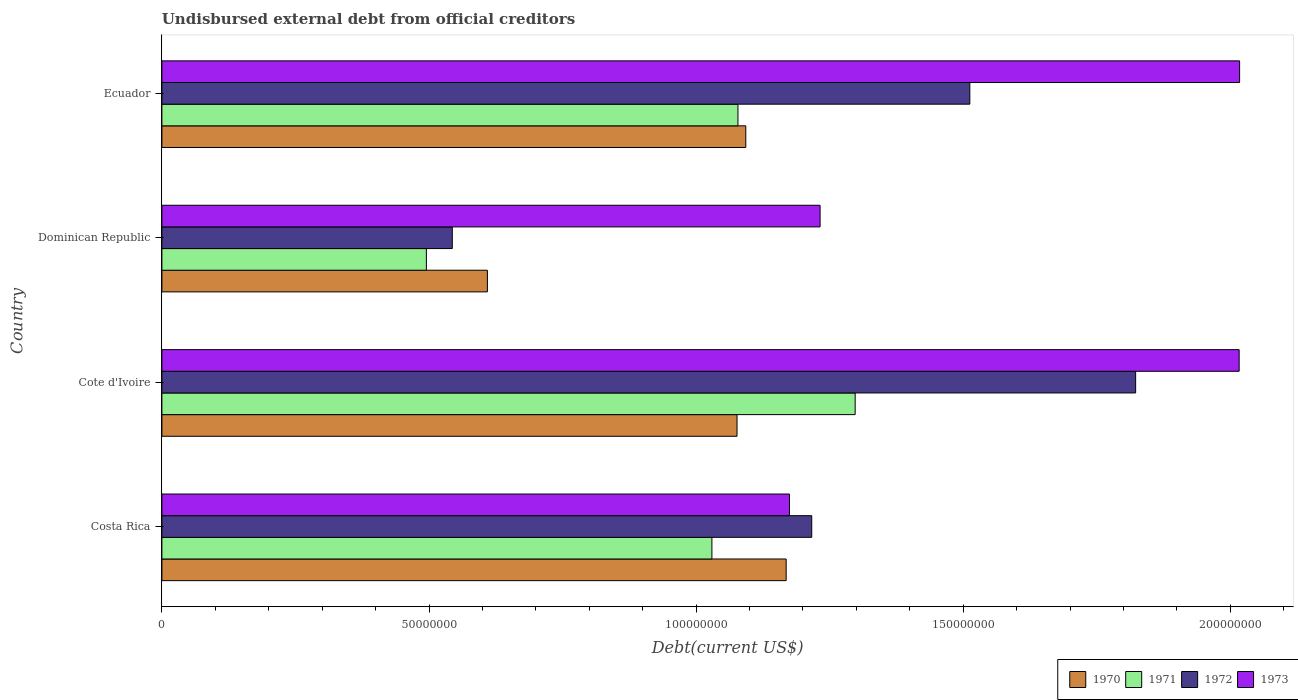How many different coloured bars are there?
Provide a succinct answer. 4. How many groups of bars are there?
Make the answer very short. 4. How many bars are there on the 3rd tick from the top?
Keep it short and to the point. 4. What is the label of the 3rd group of bars from the top?
Provide a succinct answer. Cote d'Ivoire. What is the total debt in 1972 in Costa Rica?
Offer a terse response. 1.22e+08. Across all countries, what is the maximum total debt in 1973?
Keep it short and to the point. 2.02e+08. Across all countries, what is the minimum total debt in 1970?
Offer a terse response. 6.09e+07. What is the total total debt in 1973 in the graph?
Provide a short and direct response. 6.44e+08. What is the difference between the total debt in 1971 in Dominican Republic and that in Ecuador?
Keep it short and to the point. -5.83e+07. What is the difference between the total debt in 1972 in Costa Rica and the total debt in 1970 in Cote d'Ivoire?
Make the answer very short. 1.40e+07. What is the average total debt in 1973 per country?
Your answer should be very brief. 1.61e+08. What is the difference between the total debt in 1971 and total debt in 1972 in Ecuador?
Your answer should be very brief. -4.34e+07. What is the ratio of the total debt in 1970 in Dominican Republic to that in Ecuador?
Offer a very short reply. 0.56. Is the total debt in 1970 in Costa Rica less than that in Cote d'Ivoire?
Give a very brief answer. No. Is the difference between the total debt in 1971 in Costa Rica and Ecuador greater than the difference between the total debt in 1972 in Costa Rica and Ecuador?
Your response must be concise. Yes. What is the difference between the highest and the second highest total debt in 1972?
Your answer should be compact. 3.10e+07. What is the difference between the highest and the lowest total debt in 1972?
Offer a terse response. 1.28e+08. In how many countries, is the total debt in 1972 greater than the average total debt in 1972 taken over all countries?
Offer a terse response. 2. What does the 3rd bar from the top in Ecuador represents?
Your answer should be compact. 1971. Is it the case that in every country, the sum of the total debt in 1971 and total debt in 1970 is greater than the total debt in 1972?
Give a very brief answer. Yes. How many bars are there?
Your answer should be compact. 16. Does the graph contain grids?
Make the answer very short. No. How many legend labels are there?
Provide a short and direct response. 4. How are the legend labels stacked?
Offer a terse response. Horizontal. What is the title of the graph?
Provide a succinct answer. Undisbursed external debt from official creditors. Does "2002" appear as one of the legend labels in the graph?
Keep it short and to the point. No. What is the label or title of the X-axis?
Ensure brevity in your answer.  Debt(current US$). What is the label or title of the Y-axis?
Offer a terse response. Country. What is the Debt(current US$) in 1970 in Costa Rica?
Provide a short and direct response. 1.17e+08. What is the Debt(current US$) in 1971 in Costa Rica?
Provide a succinct answer. 1.03e+08. What is the Debt(current US$) in 1972 in Costa Rica?
Ensure brevity in your answer.  1.22e+08. What is the Debt(current US$) of 1973 in Costa Rica?
Your answer should be compact. 1.17e+08. What is the Debt(current US$) of 1970 in Cote d'Ivoire?
Give a very brief answer. 1.08e+08. What is the Debt(current US$) of 1971 in Cote d'Ivoire?
Provide a succinct answer. 1.30e+08. What is the Debt(current US$) in 1972 in Cote d'Ivoire?
Provide a short and direct response. 1.82e+08. What is the Debt(current US$) of 1973 in Cote d'Ivoire?
Your response must be concise. 2.02e+08. What is the Debt(current US$) in 1970 in Dominican Republic?
Keep it short and to the point. 6.09e+07. What is the Debt(current US$) of 1971 in Dominican Republic?
Your answer should be compact. 4.95e+07. What is the Debt(current US$) in 1972 in Dominican Republic?
Provide a succinct answer. 5.44e+07. What is the Debt(current US$) in 1973 in Dominican Republic?
Ensure brevity in your answer.  1.23e+08. What is the Debt(current US$) in 1970 in Ecuador?
Provide a short and direct response. 1.09e+08. What is the Debt(current US$) in 1971 in Ecuador?
Offer a very short reply. 1.08e+08. What is the Debt(current US$) in 1972 in Ecuador?
Give a very brief answer. 1.51e+08. What is the Debt(current US$) of 1973 in Ecuador?
Provide a succinct answer. 2.02e+08. Across all countries, what is the maximum Debt(current US$) of 1970?
Offer a terse response. 1.17e+08. Across all countries, what is the maximum Debt(current US$) in 1971?
Give a very brief answer. 1.30e+08. Across all countries, what is the maximum Debt(current US$) of 1972?
Keep it short and to the point. 1.82e+08. Across all countries, what is the maximum Debt(current US$) in 1973?
Offer a very short reply. 2.02e+08. Across all countries, what is the minimum Debt(current US$) in 1970?
Your answer should be compact. 6.09e+07. Across all countries, what is the minimum Debt(current US$) in 1971?
Your answer should be compact. 4.95e+07. Across all countries, what is the minimum Debt(current US$) of 1972?
Give a very brief answer. 5.44e+07. Across all countries, what is the minimum Debt(current US$) in 1973?
Give a very brief answer. 1.17e+08. What is the total Debt(current US$) of 1970 in the graph?
Keep it short and to the point. 3.95e+08. What is the total Debt(current US$) in 1971 in the graph?
Your answer should be very brief. 3.90e+08. What is the total Debt(current US$) of 1972 in the graph?
Ensure brevity in your answer.  5.09e+08. What is the total Debt(current US$) of 1973 in the graph?
Your answer should be very brief. 6.44e+08. What is the difference between the Debt(current US$) of 1970 in Costa Rica and that in Cote d'Ivoire?
Your response must be concise. 9.20e+06. What is the difference between the Debt(current US$) in 1971 in Costa Rica and that in Cote d'Ivoire?
Provide a succinct answer. -2.68e+07. What is the difference between the Debt(current US$) of 1972 in Costa Rica and that in Cote d'Ivoire?
Your response must be concise. -6.06e+07. What is the difference between the Debt(current US$) of 1973 in Costa Rica and that in Cote d'Ivoire?
Offer a terse response. -8.42e+07. What is the difference between the Debt(current US$) of 1970 in Costa Rica and that in Dominican Republic?
Give a very brief answer. 5.59e+07. What is the difference between the Debt(current US$) of 1971 in Costa Rica and that in Dominican Republic?
Your answer should be very brief. 5.34e+07. What is the difference between the Debt(current US$) in 1972 in Costa Rica and that in Dominican Republic?
Your answer should be very brief. 6.73e+07. What is the difference between the Debt(current US$) of 1973 in Costa Rica and that in Dominican Republic?
Your answer should be compact. -5.73e+06. What is the difference between the Debt(current US$) of 1970 in Costa Rica and that in Ecuador?
Provide a succinct answer. 7.56e+06. What is the difference between the Debt(current US$) in 1971 in Costa Rica and that in Ecuador?
Ensure brevity in your answer.  -4.88e+06. What is the difference between the Debt(current US$) in 1972 in Costa Rica and that in Ecuador?
Make the answer very short. -2.96e+07. What is the difference between the Debt(current US$) in 1973 in Costa Rica and that in Ecuador?
Offer a terse response. -8.43e+07. What is the difference between the Debt(current US$) in 1970 in Cote d'Ivoire and that in Dominican Republic?
Offer a terse response. 4.67e+07. What is the difference between the Debt(current US$) in 1971 in Cote d'Ivoire and that in Dominican Republic?
Ensure brevity in your answer.  8.03e+07. What is the difference between the Debt(current US$) of 1972 in Cote d'Ivoire and that in Dominican Republic?
Provide a succinct answer. 1.28e+08. What is the difference between the Debt(current US$) in 1973 in Cote d'Ivoire and that in Dominican Republic?
Keep it short and to the point. 7.84e+07. What is the difference between the Debt(current US$) of 1970 in Cote d'Ivoire and that in Ecuador?
Your answer should be compact. -1.64e+06. What is the difference between the Debt(current US$) in 1971 in Cote d'Ivoire and that in Ecuador?
Your response must be concise. 2.19e+07. What is the difference between the Debt(current US$) of 1972 in Cote d'Ivoire and that in Ecuador?
Give a very brief answer. 3.10e+07. What is the difference between the Debt(current US$) of 1973 in Cote d'Ivoire and that in Ecuador?
Make the answer very short. -8.40e+04. What is the difference between the Debt(current US$) in 1970 in Dominican Republic and that in Ecuador?
Provide a short and direct response. -4.84e+07. What is the difference between the Debt(current US$) of 1971 in Dominican Republic and that in Ecuador?
Offer a very short reply. -5.83e+07. What is the difference between the Debt(current US$) in 1972 in Dominican Republic and that in Ecuador?
Your response must be concise. -9.69e+07. What is the difference between the Debt(current US$) in 1973 in Dominican Republic and that in Ecuador?
Make the answer very short. -7.85e+07. What is the difference between the Debt(current US$) in 1970 in Costa Rica and the Debt(current US$) in 1971 in Cote d'Ivoire?
Your answer should be very brief. -1.29e+07. What is the difference between the Debt(current US$) in 1970 in Costa Rica and the Debt(current US$) in 1972 in Cote d'Ivoire?
Your answer should be very brief. -6.54e+07. What is the difference between the Debt(current US$) in 1970 in Costa Rica and the Debt(current US$) in 1973 in Cote d'Ivoire?
Make the answer very short. -8.48e+07. What is the difference between the Debt(current US$) in 1971 in Costa Rica and the Debt(current US$) in 1972 in Cote d'Ivoire?
Give a very brief answer. -7.93e+07. What is the difference between the Debt(current US$) of 1971 in Costa Rica and the Debt(current US$) of 1973 in Cote d'Ivoire?
Offer a very short reply. -9.87e+07. What is the difference between the Debt(current US$) in 1972 in Costa Rica and the Debt(current US$) in 1973 in Cote d'Ivoire?
Ensure brevity in your answer.  -8.00e+07. What is the difference between the Debt(current US$) in 1970 in Costa Rica and the Debt(current US$) in 1971 in Dominican Republic?
Provide a short and direct response. 6.73e+07. What is the difference between the Debt(current US$) of 1970 in Costa Rica and the Debt(current US$) of 1972 in Dominican Republic?
Provide a short and direct response. 6.25e+07. What is the difference between the Debt(current US$) in 1970 in Costa Rica and the Debt(current US$) in 1973 in Dominican Republic?
Offer a terse response. -6.35e+06. What is the difference between the Debt(current US$) in 1971 in Costa Rica and the Debt(current US$) in 1972 in Dominican Republic?
Give a very brief answer. 4.86e+07. What is the difference between the Debt(current US$) in 1971 in Costa Rica and the Debt(current US$) in 1973 in Dominican Republic?
Give a very brief answer. -2.02e+07. What is the difference between the Debt(current US$) in 1972 in Costa Rica and the Debt(current US$) in 1973 in Dominican Republic?
Keep it short and to the point. -1.56e+06. What is the difference between the Debt(current US$) of 1970 in Costa Rica and the Debt(current US$) of 1971 in Ecuador?
Your answer should be very brief. 9.03e+06. What is the difference between the Debt(current US$) in 1970 in Costa Rica and the Debt(current US$) in 1972 in Ecuador?
Provide a succinct answer. -3.44e+07. What is the difference between the Debt(current US$) of 1970 in Costa Rica and the Debt(current US$) of 1973 in Ecuador?
Your response must be concise. -8.49e+07. What is the difference between the Debt(current US$) of 1971 in Costa Rica and the Debt(current US$) of 1972 in Ecuador?
Your answer should be very brief. -4.83e+07. What is the difference between the Debt(current US$) in 1971 in Costa Rica and the Debt(current US$) in 1973 in Ecuador?
Provide a succinct answer. -9.88e+07. What is the difference between the Debt(current US$) of 1972 in Costa Rica and the Debt(current US$) of 1973 in Ecuador?
Offer a very short reply. -8.01e+07. What is the difference between the Debt(current US$) of 1970 in Cote d'Ivoire and the Debt(current US$) of 1971 in Dominican Republic?
Your answer should be very brief. 5.81e+07. What is the difference between the Debt(current US$) in 1970 in Cote d'Ivoire and the Debt(current US$) in 1972 in Dominican Republic?
Provide a succinct answer. 5.33e+07. What is the difference between the Debt(current US$) in 1970 in Cote d'Ivoire and the Debt(current US$) in 1973 in Dominican Republic?
Offer a very short reply. -1.55e+07. What is the difference between the Debt(current US$) of 1971 in Cote d'Ivoire and the Debt(current US$) of 1972 in Dominican Republic?
Your response must be concise. 7.54e+07. What is the difference between the Debt(current US$) in 1971 in Cote d'Ivoire and the Debt(current US$) in 1973 in Dominican Republic?
Provide a short and direct response. 6.57e+06. What is the difference between the Debt(current US$) of 1972 in Cote d'Ivoire and the Debt(current US$) of 1973 in Dominican Republic?
Provide a succinct answer. 5.91e+07. What is the difference between the Debt(current US$) in 1970 in Cote d'Ivoire and the Debt(current US$) in 1971 in Ecuador?
Your answer should be compact. -1.73e+05. What is the difference between the Debt(current US$) in 1970 in Cote d'Ivoire and the Debt(current US$) in 1972 in Ecuador?
Give a very brief answer. -4.36e+07. What is the difference between the Debt(current US$) in 1970 in Cote d'Ivoire and the Debt(current US$) in 1973 in Ecuador?
Make the answer very short. -9.41e+07. What is the difference between the Debt(current US$) in 1971 in Cote d'Ivoire and the Debt(current US$) in 1972 in Ecuador?
Offer a very short reply. -2.15e+07. What is the difference between the Debt(current US$) of 1971 in Cote d'Ivoire and the Debt(current US$) of 1973 in Ecuador?
Your response must be concise. -7.20e+07. What is the difference between the Debt(current US$) in 1972 in Cote d'Ivoire and the Debt(current US$) in 1973 in Ecuador?
Give a very brief answer. -1.95e+07. What is the difference between the Debt(current US$) of 1970 in Dominican Republic and the Debt(current US$) of 1971 in Ecuador?
Your answer should be compact. -4.69e+07. What is the difference between the Debt(current US$) in 1970 in Dominican Republic and the Debt(current US$) in 1972 in Ecuador?
Provide a short and direct response. -9.03e+07. What is the difference between the Debt(current US$) of 1970 in Dominican Republic and the Debt(current US$) of 1973 in Ecuador?
Provide a short and direct response. -1.41e+08. What is the difference between the Debt(current US$) in 1971 in Dominican Republic and the Debt(current US$) in 1972 in Ecuador?
Offer a terse response. -1.02e+08. What is the difference between the Debt(current US$) in 1971 in Dominican Republic and the Debt(current US$) in 1973 in Ecuador?
Provide a succinct answer. -1.52e+08. What is the difference between the Debt(current US$) in 1972 in Dominican Republic and the Debt(current US$) in 1973 in Ecuador?
Give a very brief answer. -1.47e+08. What is the average Debt(current US$) of 1970 per country?
Your response must be concise. 9.87e+07. What is the average Debt(current US$) in 1971 per country?
Your answer should be compact. 9.75e+07. What is the average Debt(current US$) in 1972 per country?
Your answer should be very brief. 1.27e+08. What is the average Debt(current US$) of 1973 per country?
Your answer should be very brief. 1.61e+08. What is the difference between the Debt(current US$) of 1970 and Debt(current US$) of 1971 in Costa Rica?
Make the answer very short. 1.39e+07. What is the difference between the Debt(current US$) in 1970 and Debt(current US$) in 1972 in Costa Rica?
Offer a terse response. -4.78e+06. What is the difference between the Debt(current US$) of 1970 and Debt(current US$) of 1973 in Costa Rica?
Offer a terse response. -6.18e+05. What is the difference between the Debt(current US$) of 1971 and Debt(current US$) of 1972 in Costa Rica?
Provide a succinct answer. -1.87e+07. What is the difference between the Debt(current US$) of 1971 and Debt(current US$) of 1973 in Costa Rica?
Your answer should be very brief. -1.45e+07. What is the difference between the Debt(current US$) in 1972 and Debt(current US$) in 1973 in Costa Rica?
Make the answer very short. 4.17e+06. What is the difference between the Debt(current US$) in 1970 and Debt(current US$) in 1971 in Cote d'Ivoire?
Give a very brief answer. -2.21e+07. What is the difference between the Debt(current US$) in 1970 and Debt(current US$) in 1972 in Cote d'Ivoire?
Ensure brevity in your answer.  -7.46e+07. What is the difference between the Debt(current US$) of 1970 and Debt(current US$) of 1973 in Cote d'Ivoire?
Ensure brevity in your answer.  -9.40e+07. What is the difference between the Debt(current US$) of 1971 and Debt(current US$) of 1972 in Cote d'Ivoire?
Provide a short and direct response. -5.25e+07. What is the difference between the Debt(current US$) in 1971 and Debt(current US$) in 1973 in Cote d'Ivoire?
Ensure brevity in your answer.  -7.19e+07. What is the difference between the Debt(current US$) in 1972 and Debt(current US$) in 1973 in Cote d'Ivoire?
Your response must be concise. -1.94e+07. What is the difference between the Debt(current US$) of 1970 and Debt(current US$) of 1971 in Dominican Republic?
Provide a succinct answer. 1.14e+07. What is the difference between the Debt(current US$) of 1970 and Debt(current US$) of 1972 in Dominican Republic?
Provide a short and direct response. 6.57e+06. What is the difference between the Debt(current US$) of 1970 and Debt(current US$) of 1973 in Dominican Republic?
Offer a very short reply. -6.23e+07. What is the difference between the Debt(current US$) of 1971 and Debt(current US$) of 1972 in Dominican Republic?
Your answer should be compact. -4.85e+06. What is the difference between the Debt(current US$) in 1971 and Debt(current US$) in 1973 in Dominican Republic?
Your answer should be very brief. -7.37e+07. What is the difference between the Debt(current US$) in 1972 and Debt(current US$) in 1973 in Dominican Republic?
Your response must be concise. -6.88e+07. What is the difference between the Debt(current US$) in 1970 and Debt(current US$) in 1971 in Ecuador?
Offer a terse response. 1.47e+06. What is the difference between the Debt(current US$) in 1970 and Debt(current US$) in 1972 in Ecuador?
Offer a very short reply. -4.19e+07. What is the difference between the Debt(current US$) of 1970 and Debt(current US$) of 1973 in Ecuador?
Your answer should be very brief. -9.24e+07. What is the difference between the Debt(current US$) in 1971 and Debt(current US$) in 1972 in Ecuador?
Give a very brief answer. -4.34e+07. What is the difference between the Debt(current US$) in 1971 and Debt(current US$) in 1973 in Ecuador?
Provide a short and direct response. -9.39e+07. What is the difference between the Debt(current US$) in 1972 and Debt(current US$) in 1973 in Ecuador?
Ensure brevity in your answer.  -5.05e+07. What is the ratio of the Debt(current US$) in 1970 in Costa Rica to that in Cote d'Ivoire?
Your answer should be compact. 1.09. What is the ratio of the Debt(current US$) of 1971 in Costa Rica to that in Cote d'Ivoire?
Offer a terse response. 0.79. What is the ratio of the Debt(current US$) in 1972 in Costa Rica to that in Cote d'Ivoire?
Provide a succinct answer. 0.67. What is the ratio of the Debt(current US$) of 1973 in Costa Rica to that in Cote d'Ivoire?
Give a very brief answer. 0.58. What is the ratio of the Debt(current US$) in 1970 in Costa Rica to that in Dominican Republic?
Offer a very short reply. 1.92. What is the ratio of the Debt(current US$) of 1971 in Costa Rica to that in Dominican Republic?
Keep it short and to the point. 2.08. What is the ratio of the Debt(current US$) in 1972 in Costa Rica to that in Dominican Republic?
Offer a terse response. 2.24. What is the ratio of the Debt(current US$) in 1973 in Costa Rica to that in Dominican Republic?
Provide a short and direct response. 0.95. What is the ratio of the Debt(current US$) in 1970 in Costa Rica to that in Ecuador?
Offer a terse response. 1.07. What is the ratio of the Debt(current US$) of 1971 in Costa Rica to that in Ecuador?
Keep it short and to the point. 0.95. What is the ratio of the Debt(current US$) of 1972 in Costa Rica to that in Ecuador?
Provide a succinct answer. 0.8. What is the ratio of the Debt(current US$) in 1973 in Costa Rica to that in Ecuador?
Your response must be concise. 0.58. What is the ratio of the Debt(current US$) of 1970 in Cote d'Ivoire to that in Dominican Republic?
Provide a succinct answer. 1.77. What is the ratio of the Debt(current US$) of 1971 in Cote d'Ivoire to that in Dominican Republic?
Make the answer very short. 2.62. What is the ratio of the Debt(current US$) in 1972 in Cote d'Ivoire to that in Dominican Republic?
Offer a very short reply. 3.35. What is the ratio of the Debt(current US$) in 1973 in Cote d'Ivoire to that in Dominican Republic?
Keep it short and to the point. 1.64. What is the ratio of the Debt(current US$) of 1970 in Cote d'Ivoire to that in Ecuador?
Offer a terse response. 0.98. What is the ratio of the Debt(current US$) in 1971 in Cote d'Ivoire to that in Ecuador?
Your response must be concise. 1.2. What is the ratio of the Debt(current US$) of 1972 in Cote d'Ivoire to that in Ecuador?
Ensure brevity in your answer.  1.21. What is the ratio of the Debt(current US$) of 1973 in Cote d'Ivoire to that in Ecuador?
Your answer should be compact. 1. What is the ratio of the Debt(current US$) in 1970 in Dominican Republic to that in Ecuador?
Provide a short and direct response. 0.56. What is the ratio of the Debt(current US$) of 1971 in Dominican Republic to that in Ecuador?
Your answer should be compact. 0.46. What is the ratio of the Debt(current US$) of 1972 in Dominican Republic to that in Ecuador?
Your response must be concise. 0.36. What is the ratio of the Debt(current US$) of 1973 in Dominican Republic to that in Ecuador?
Provide a short and direct response. 0.61. What is the difference between the highest and the second highest Debt(current US$) in 1970?
Provide a short and direct response. 7.56e+06. What is the difference between the highest and the second highest Debt(current US$) of 1971?
Your response must be concise. 2.19e+07. What is the difference between the highest and the second highest Debt(current US$) of 1972?
Provide a short and direct response. 3.10e+07. What is the difference between the highest and the second highest Debt(current US$) of 1973?
Make the answer very short. 8.40e+04. What is the difference between the highest and the lowest Debt(current US$) of 1970?
Your response must be concise. 5.59e+07. What is the difference between the highest and the lowest Debt(current US$) of 1971?
Your answer should be compact. 8.03e+07. What is the difference between the highest and the lowest Debt(current US$) of 1972?
Keep it short and to the point. 1.28e+08. What is the difference between the highest and the lowest Debt(current US$) of 1973?
Provide a short and direct response. 8.43e+07. 